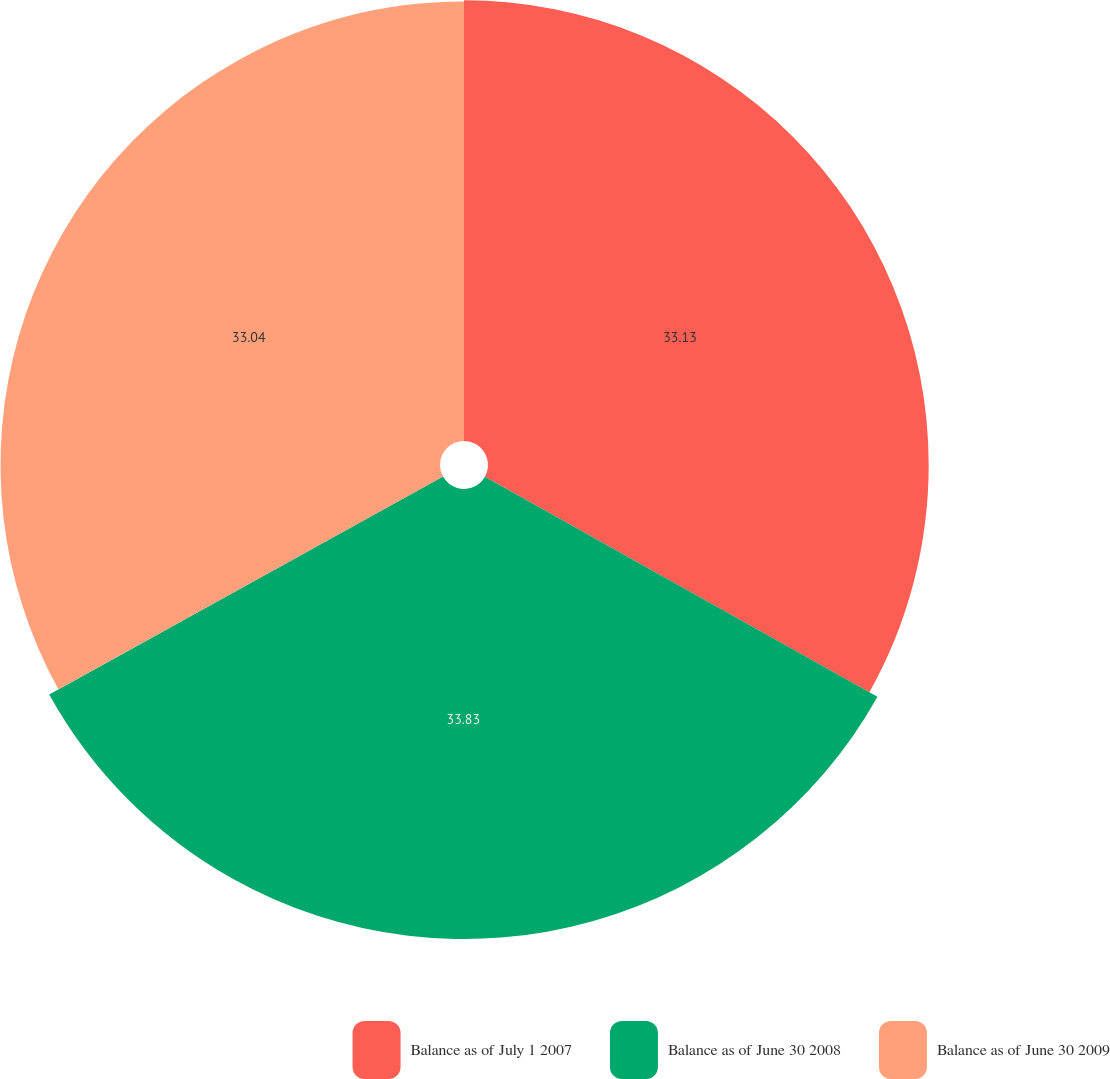Convert chart to OTSL. <chart><loc_0><loc_0><loc_500><loc_500><pie_chart><fcel>Balance as of July 1 2007<fcel>Balance as of June 30 2008<fcel>Balance as of June 30 2009<nl><fcel>33.13%<fcel>33.83%<fcel>33.04%<nl></chart> 